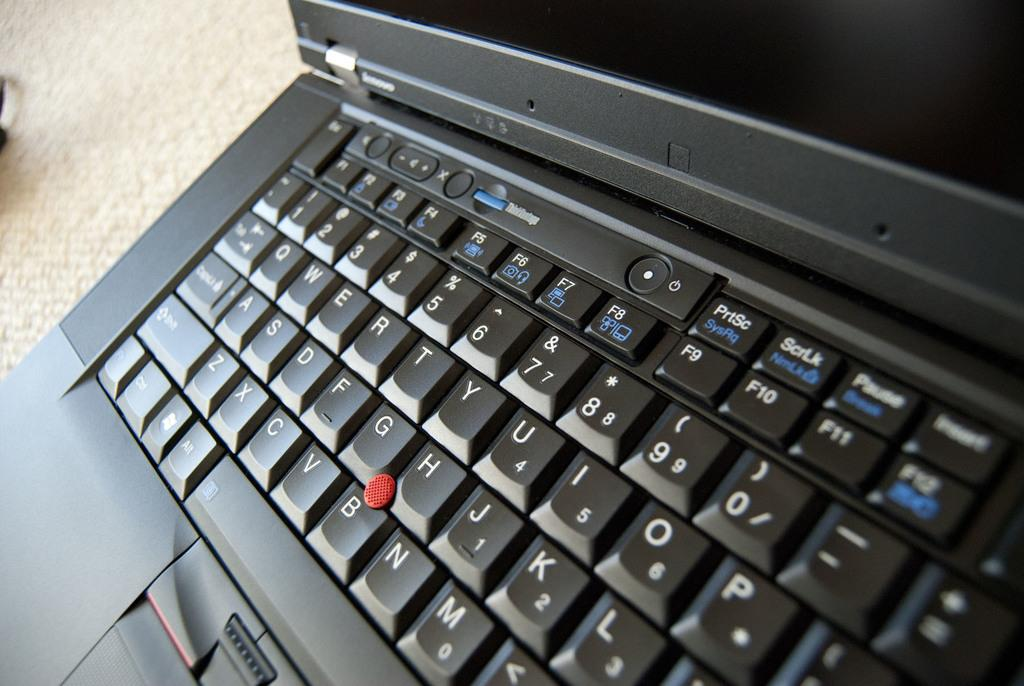<image>
Present a compact description of the photo's key features. Black Lenovo laptop with a key that has PriSc in white and SysRq in blue. 